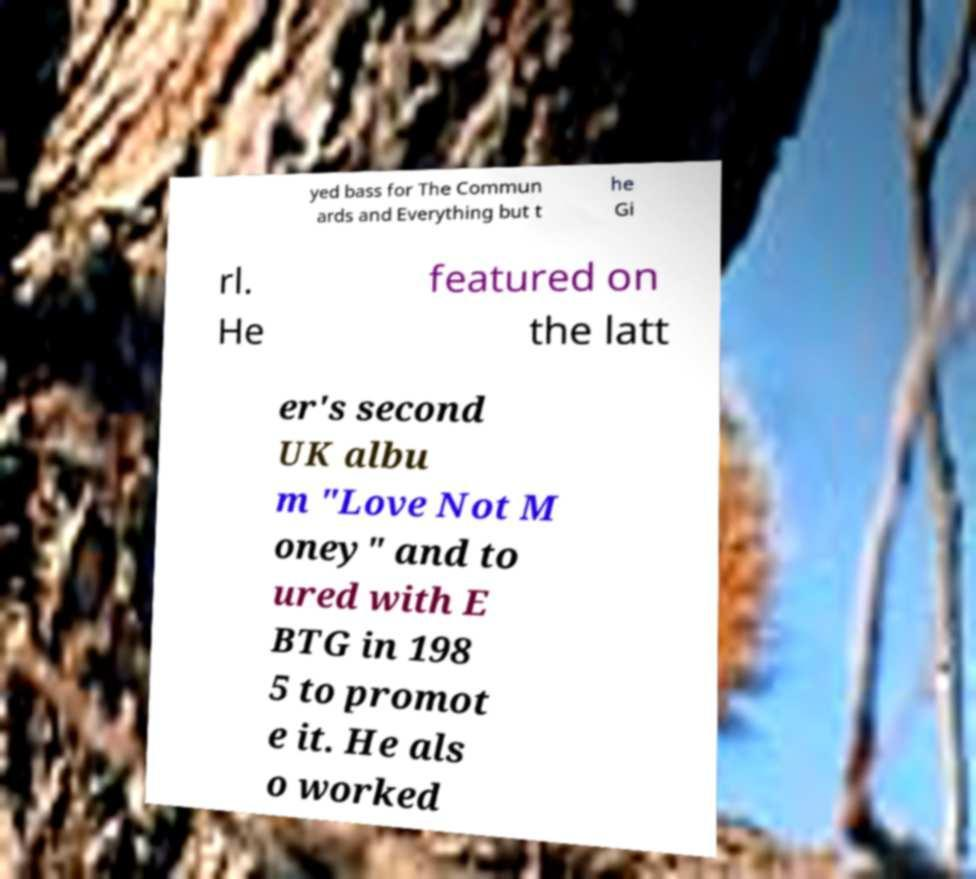For documentation purposes, I need the text within this image transcribed. Could you provide that? yed bass for The Commun ards and Everything but t he Gi rl. He featured on the latt er's second UK albu m "Love Not M oney" and to ured with E BTG in 198 5 to promot e it. He als o worked 